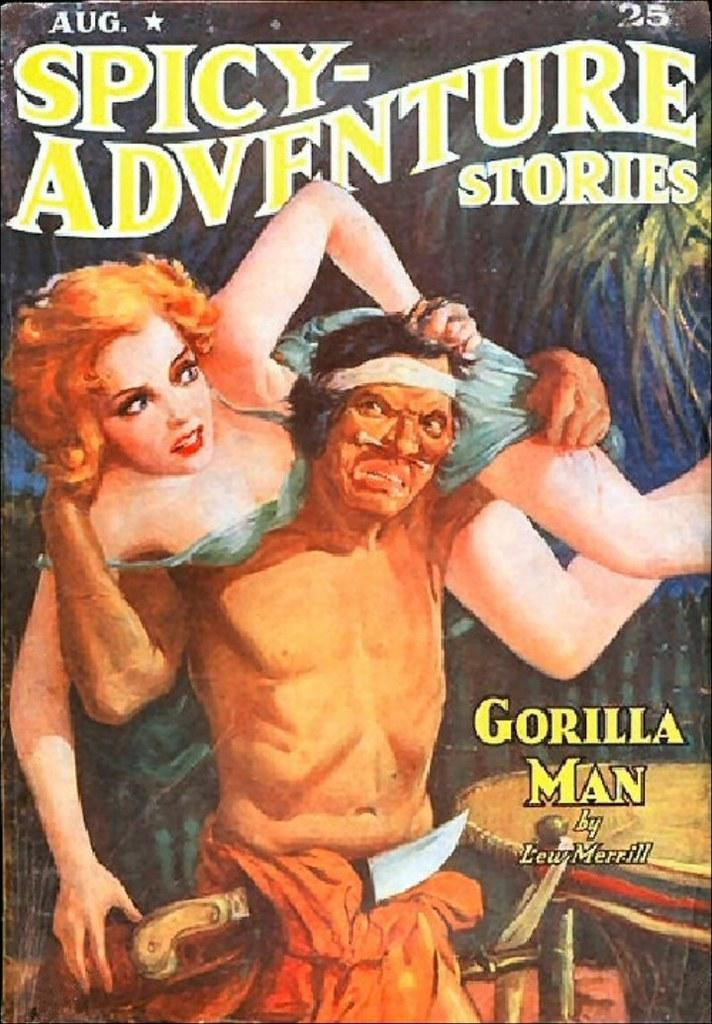What is featured on the poster in the image? The poster depicts people. Where is the text located on the poster? There is text on the top side and the bottom right side of the image. How many spiders are crawling on the poster in the image? There are no spiders present on the poster in the image. What impulse might the people depicted on the poster be experiencing? The image does not provide information about the emotions or impulses of the people depicted on the poster. --- Facts: 1. There is a car in the image. 2. The car is red. 3. The car has four wheels. 4. There is a person sitting in the car. 5. The person is wearing a hat. Absurd Topics: parrot, dance, ocean Conversation: What is the main subject of the image? The main subject of the image is a car. What color is the car? The car is red. How many wheels does the car have? The car has four wheels. Is there anyone inside the car? Yes, there is a person sitting in the car. What is the person wearing? The person is wearing a hat. Reasoning: Let's think step by step in order to produce the conversation. We start by identifying the main subject in the image, which is the car. Then, we describe the car's color and the number of wheels it has. Next, we mention the presence of a person inside the car and describe what they are wearing. Each question is designed to elicit a specific detail about the image that is known from the provided facts. Absurd Question/Answer: Can you see a parrot dancing in the ocean in the image? No, there is no parrot or ocean present in the image. 